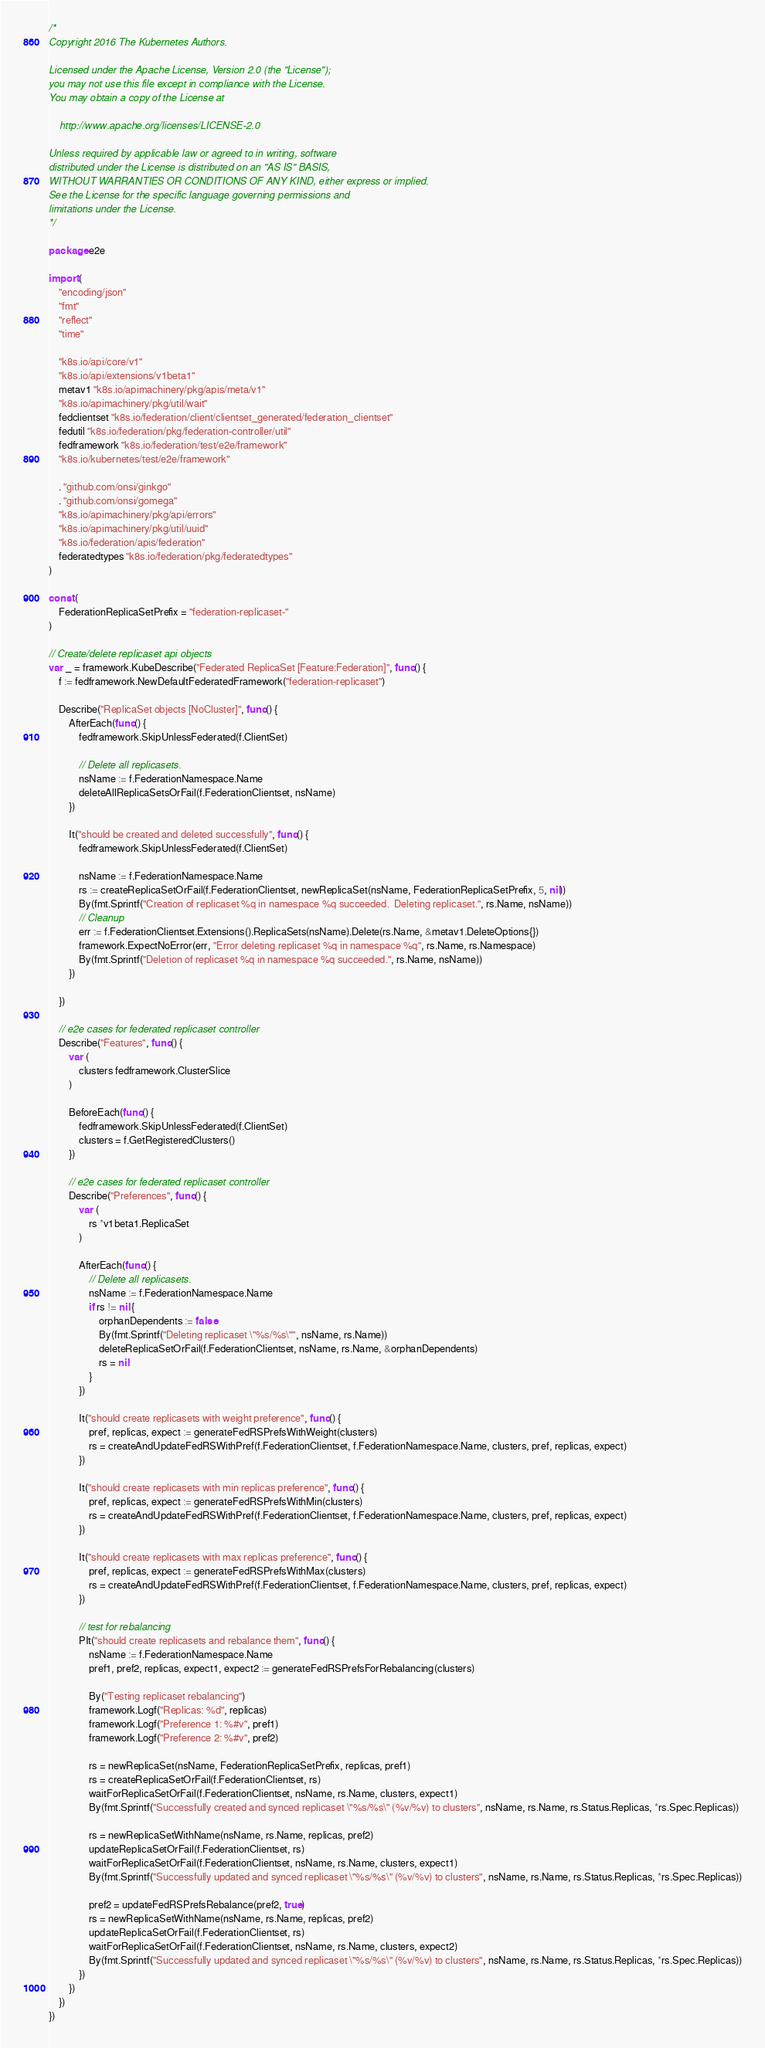Convert code to text. <code><loc_0><loc_0><loc_500><loc_500><_Go_>/*
Copyright 2016 The Kubernetes Authors.

Licensed under the Apache License, Version 2.0 (the "License");
you may not use this file except in compliance with the License.
You may obtain a copy of the License at

    http://www.apache.org/licenses/LICENSE-2.0

Unless required by applicable law or agreed to in writing, software
distributed under the License is distributed on an "AS IS" BASIS,
WITHOUT WARRANTIES OR CONDITIONS OF ANY KIND, either express or implied.
See the License for the specific language governing permissions and
limitations under the License.
*/

package e2e

import (
	"encoding/json"
	"fmt"
	"reflect"
	"time"

	"k8s.io/api/core/v1"
	"k8s.io/api/extensions/v1beta1"
	metav1 "k8s.io/apimachinery/pkg/apis/meta/v1"
	"k8s.io/apimachinery/pkg/util/wait"
	fedclientset "k8s.io/federation/client/clientset_generated/federation_clientset"
	fedutil "k8s.io/federation/pkg/federation-controller/util"
	fedframework "k8s.io/federation/test/e2e/framework"
	"k8s.io/kubernetes/test/e2e/framework"

	. "github.com/onsi/ginkgo"
	. "github.com/onsi/gomega"
	"k8s.io/apimachinery/pkg/api/errors"
	"k8s.io/apimachinery/pkg/util/uuid"
	"k8s.io/federation/apis/federation"
	federatedtypes "k8s.io/federation/pkg/federatedtypes"
)

const (
	FederationReplicaSetPrefix = "federation-replicaset-"
)

// Create/delete replicaset api objects
var _ = framework.KubeDescribe("Federated ReplicaSet [Feature:Federation]", func() {
	f := fedframework.NewDefaultFederatedFramework("federation-replicaset")

	Describe("ReplicaSet objects [NoCluster]", func() {
		AfterEach(func() {
			fedframework.SkipUnlessFederated(f.ClientSet)

			// Delete all replicasets.
			nsName := f.FederationNamespace.Name
			deleteAllReplicaSetsOrFail(f.FederationClientset, nsName)
		})

		It("should be created and deleted successfully", func() {
			fedframework.SkipUnlessFederated(f.ClientSet)

			nsName := f.FederationNamespace.Name
			rs := createReplicaSetOrFail(f.FederationClientset, newReplicaSet(nsName, FederationReplicaSetPrefix, 5, nil))
			By(fmt.Sprintf("Creation of replicaset %q in namespace %q succeeded.  Deleting replicaset.", rs.Name, nsName))
			// Cleanup
			err := f.FederationClientset.Extensions().ReplicaSets(nsName).Delete(rs.Name, &metav1.DeleteOptions{})
			framework.ExpectNoError(err, "Error deleting replicaset %q in namespace %q", rs.Name, rs.Namespace)
			By(fmt.Sprintf("Deletion of replicaset %q in namespace %q succeeded.", rs.Name, nsName))
		})

	})

	// e2e cases for federated replicaset controller
	Describe("Features", func() {
		var (
			clusters fedframework.ClusterSlice
		)

		BeforeEach(func() {
			fedframework.SkipUnlessFederated(f.ClientSet)
			clusters = f.GetRegisteredClusters()
		})

		// e2e cases for federated replicaset controller
		Describe("Preferences", func() {
			var (
				rs *v1beta1.ReplicaSet
			)

			AfterEach(func() {
				// Delete all replicasets.
				nsName := f.FederationNamespace.Name
				if rs != nil {
					orphanDependents := false
					By(fmt.Sprintf("Deleting replicaset \"%s/%s\"", nsName, rs.Name))
					deleteReplicaSetOrFail(f.FederationClientset, nsName, rs.Name, &orphanDependents)
					rs = nil
				}
			})

			It("should create replicasets with weight preference", func() {
				pref, replicas, expect := generateFedRSPrefsWithWeight(clusters)
				rs = createAndUpdateFedRSWithPref(f.FederationClientset, f.FederationNamespace.Name, clusters, pref, replicas, expect)
			})

			It("should create replicasets with min replicas preference", func() {
				pref, replicas, expect := generateFedRSPrefsWithMin(clusters)
				rs = createAndUpdateFedRSWithPref(f.FederationClientset, f.FederationNamespace.Name, clusters, pref, replicas, expect)
			})

			It("should create replicasets with max replicas preference", func() {
				pref, replicas, expect := generateFedRSPrefsWithMax(clusters)
				rs = createAndUpdateFedRSWithPref(f.FederationClientset, f.FederationNamespace.Name, clusters, pref, replicas, expect)
			})

			// test for rebalancing
			PIt("should create replicasets and rebalance them", func() {
				nsName := f.FederationNamespace.Name
				pref1, pref2, replicas, expect1, expect2 := generateFedRSPrefsForRebalancing(clusters)

				By("Testing replicaset rebalancing")
				framework.Logf("Replicas: %d", replicas)
				framework.Logf("Preference 1: %#v", pref1)
				framework.Logf("Preference 2: %#v", pref2)

				rs = newReplicaSet(nsName, FederationReplicaSetPrefix, replicas, pref1)
				rs = createReplicaSetOrFail(f.FederationClientset, rs)
				waitForReplicaSetOrFail(f.FederationClientset, nsName, rs.Name, clusters, expect1)
				By(fmt.Sprintf("Successfully created and synced replicaset \"%s/%s\" (%v/%v) to clusters", nsName, rs.Name, rs.Status.Replicas, *rs.Spec.Replicas))

				rs = newReplicaSetWithName(nsName, rs.Name, replicas, pref2)
				updateReplicaSetOrFail(f.FederationClientset, rs)
				waitForReplicaSetOrFail(f.FederationClientset, nsName, rs.Name, clusters, expect1)
				By(fmt.Sprintf("Successfully updated and synced replicaset \"%s/%s\" (%v/%v) to clusters", nsName, rs.Name, rs.Status.Replicas, *rs.Spec.Replicas))

				pref2 = updateFedRSPrefsRebalance(pref2, true)
				rs = newReplicaSetWithName(nsName, rs.Name, replicas, pref2)
				updateReplicaSetOrFail(f.FederationClientset, rs)
				waitForReplicaSetOrFail(f.FederationClientset, nsName, rs.Name, clusters, expect2)
				By(fmt.Sprintf("Successfully updated and synced replicaset \"%s/%s\" (%v/%v) to clusters", nsName, rs.Name, rs.Status.Replicas, *rs.Spec.Replicas))
			})
		})
	})
})
</code> 